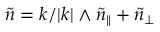Convert formula to latex. <formula><loc_0><loc_0><loc_500><loc_500>\tilde { n } = k / | k | \wedge \tilde { n } _ { \| } + \tilde { n } _ { \perp }</formula> 